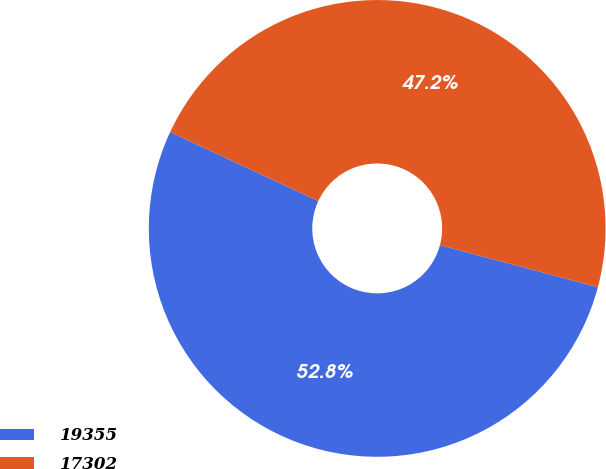Convert chart. <chart><loc_0><loc_0><loc_500><loc_500><pie_chart><fcel>19355<fcel>17302<nl><fcel>52.79%<fcel>47.21%<nl></chart> 